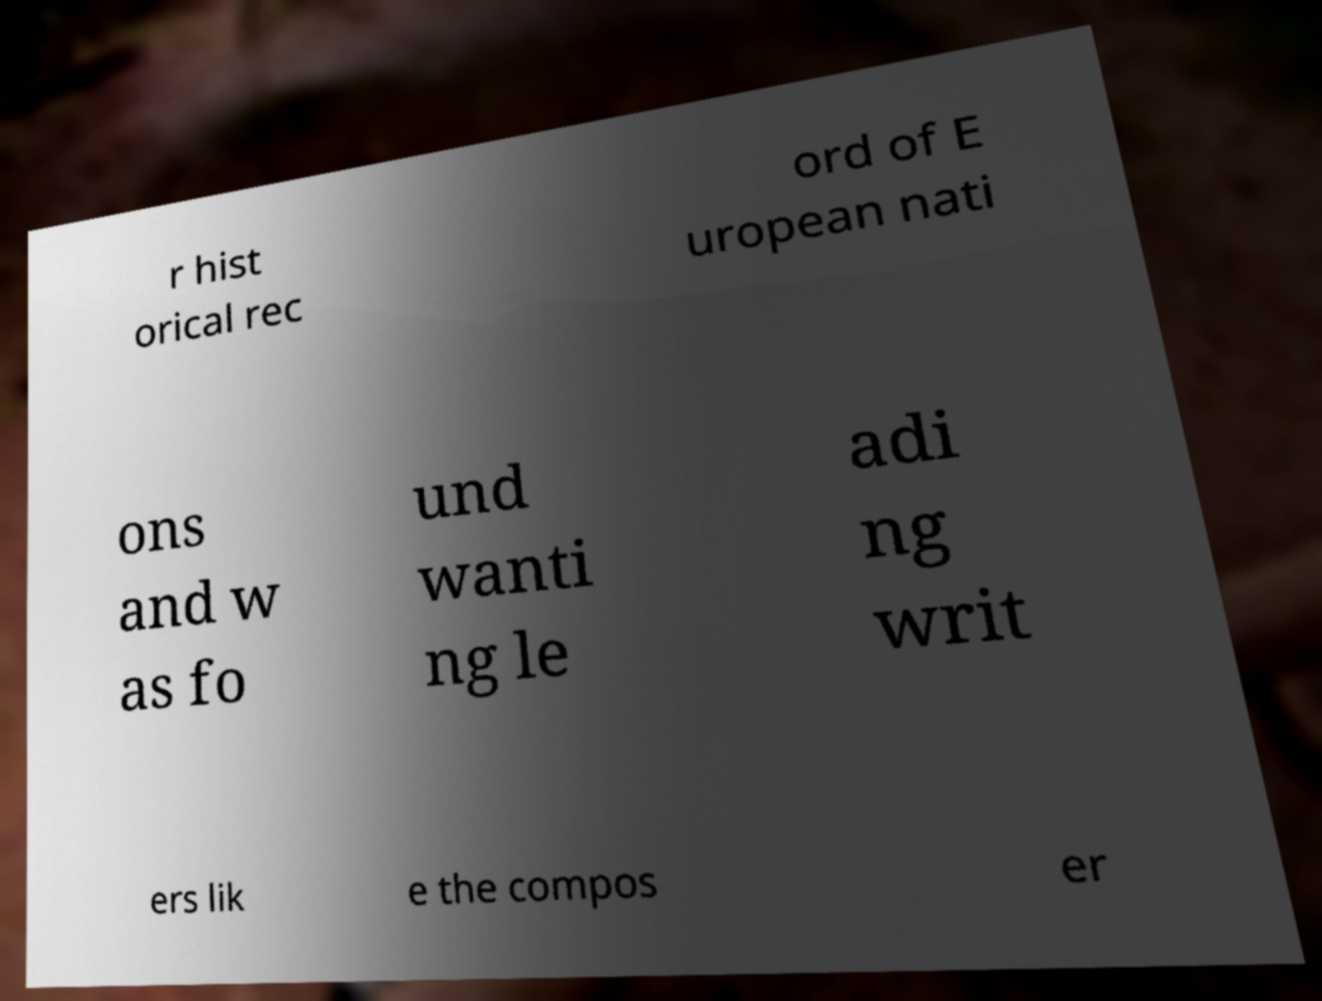Please identify and transcribe the text found in this image. r hist orical rec ord of E uropean nati ons and w as fo und wanti ng le adi ng writ ers lik e the compos er 